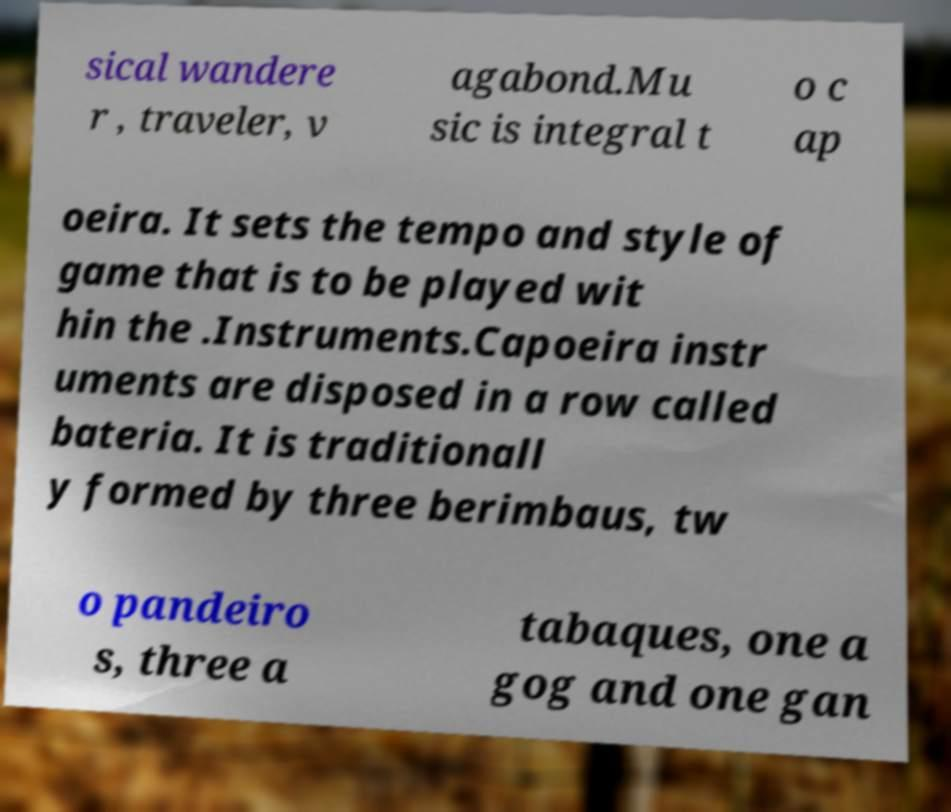Please read and relay the text visible in this image. What does it say? sical wandere r , traveler, v agabond.Mu sic is integral t o c ap oeira. It sets the tempo and style of game that is to be played wit hin the .Instruments.Capoeira instr uments are disposed in a row called bateria. It is traditionall y formed by three berimbaus, tw o pandeiro s, three a tabaques, one a gog and one gan 